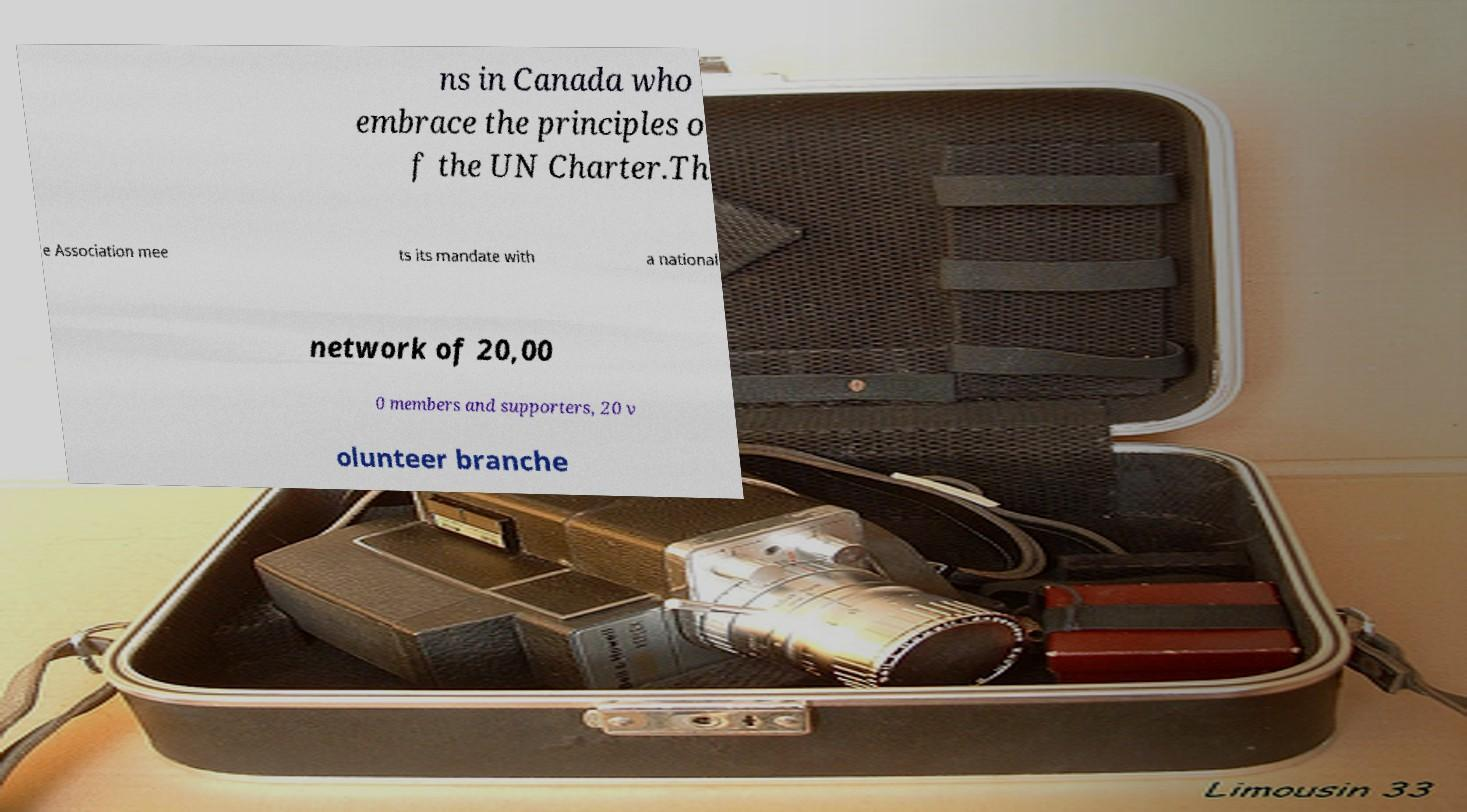For documentation purposes, I need the text within this image transcribed. Could you provide that? ns in Canada who embrace the principles o f the UN Charter.Th e Association mee ts its mandate with a national network of 20,00 0 members and supporters, 20 v olunteer branche 